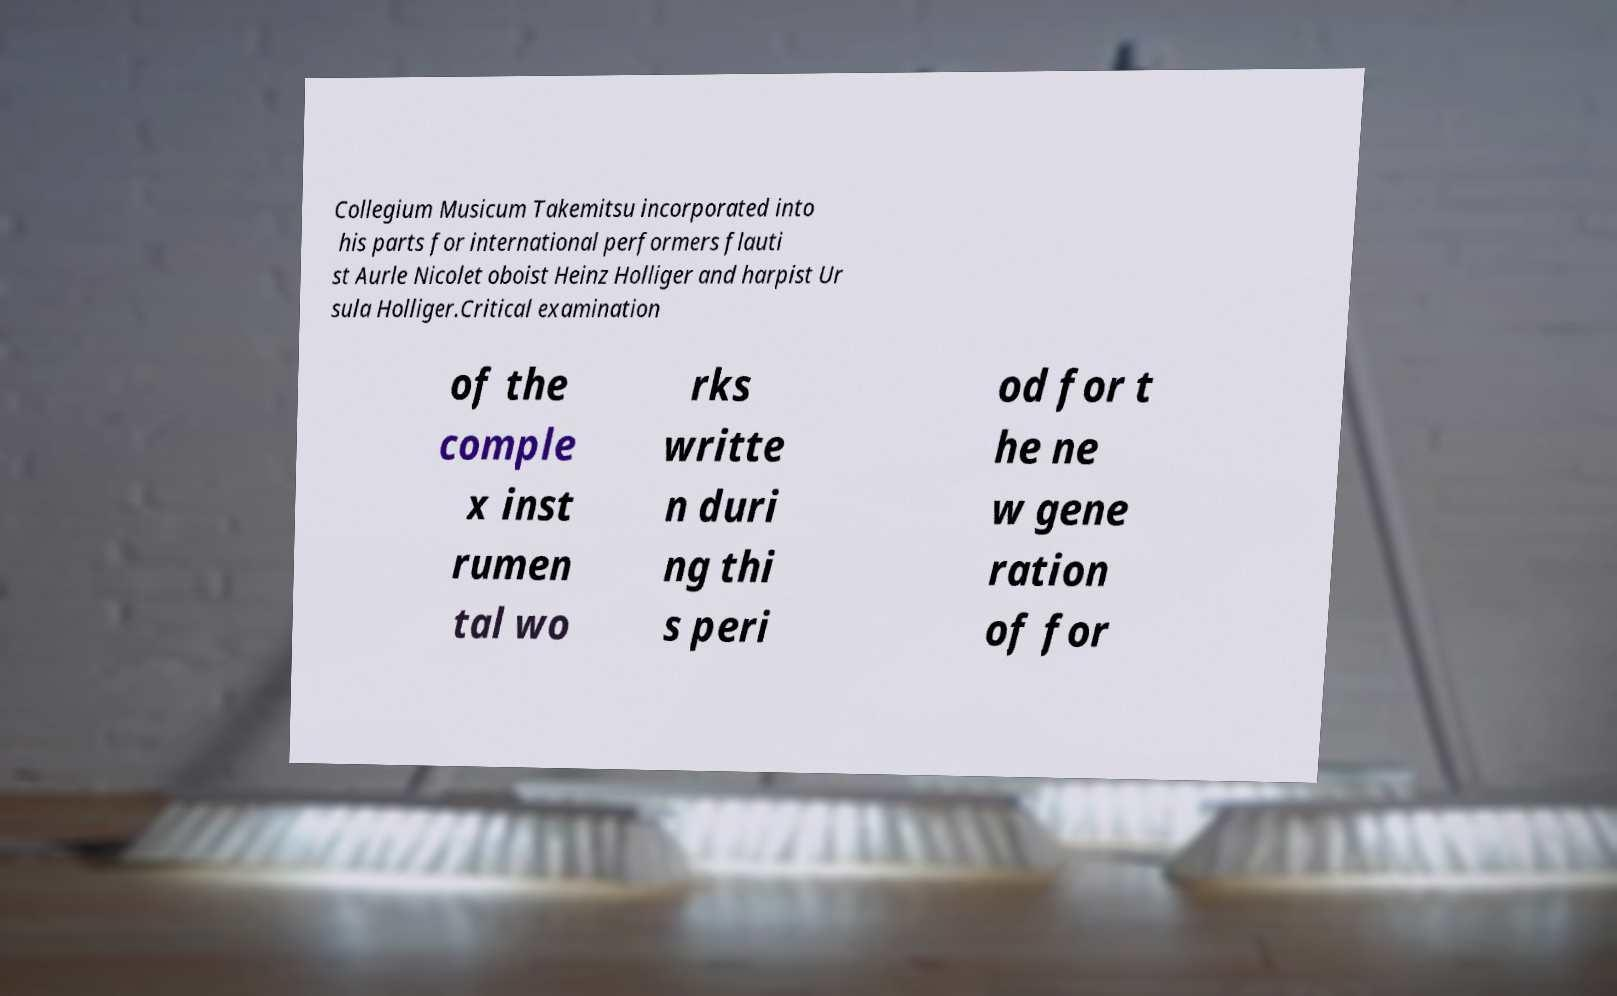There's text embedded in this image that I need extracted. Can you transcribe it verbatim? Collegium Musicum Takemitsu incorporated into his parts for international performers flauti st Aurle Nicolet oboist Heinz Holliger and harpist Ur sula Holliger.Critical examination of the comple x inst rumen tal wo rks writte n duri ng thi s peri od for t he ne w gene ration of for 